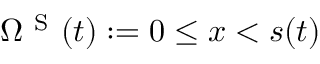<formula> <loc_0><loc_0><loc_500><loc_500>\Omega ^ { S } ( t ) \colon = 0 \leq x < s ( t )</formula> 